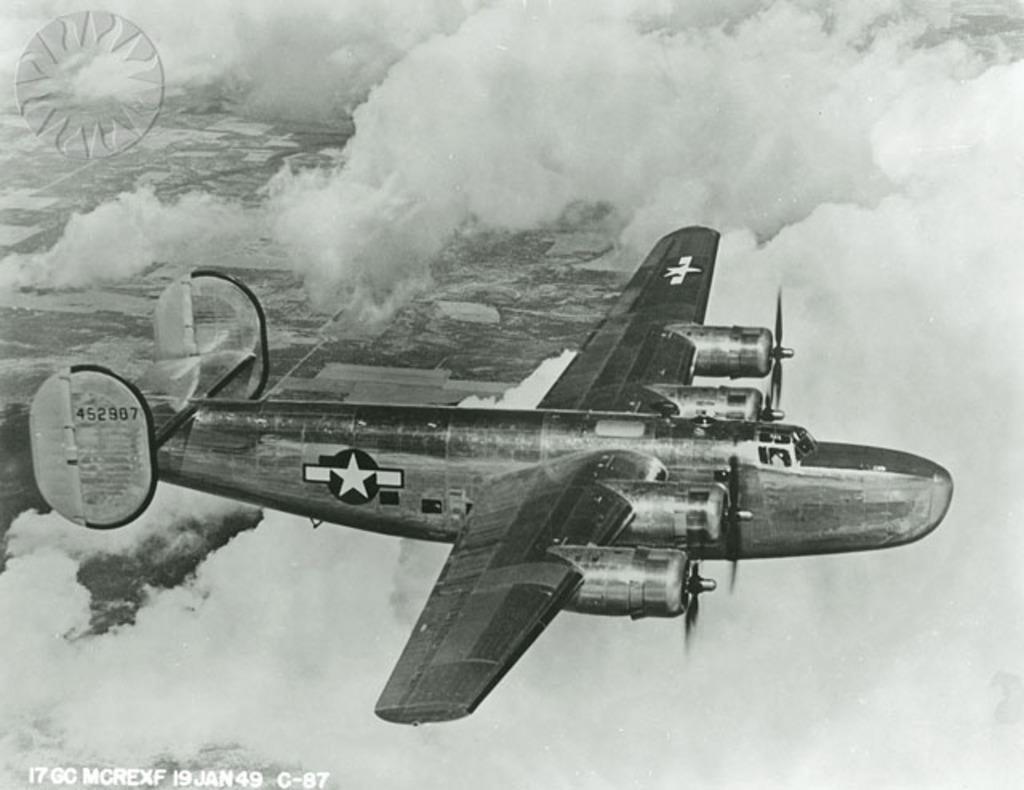<image>
Create a compact narrative representing the image presented. A United States military plane flies on January 19, 1949. 